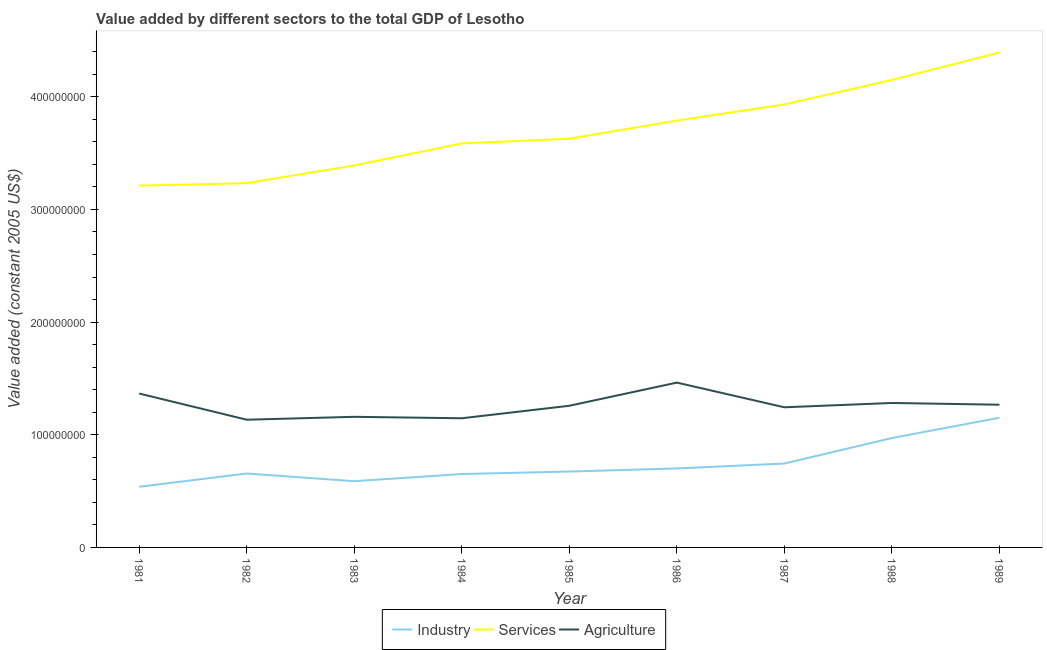Does the line corresponding to value added by agricultural sector intersect with the line corresponding to value added by industrial sector?
Offer a terse response. No. Is the number of lines equal to the number of legend labels?
Give a very brief answer. Yes. What is the value added by agricultural sector in 1989?
Offer a terse response. 1.27e+08. Across all years, what is the maximum value added by industrial sector?
Offer a very short reply. 1.15e+08. Across all years, what is the minimum value added by industrial sector?
Your answer should be compact. 5.38e+07. In which year was the value added by industrial sector maximum?
Your response must be concise. 1989. What is the total value added by industrial sector in the graph?
Provide a short and direct response. 6.68e+08. What is the difference between the value added by agricultural sector in 1982 and that in 1989?
Provide a short and direct response. -1.33e+07. What is the difference between the value added by services in 1984 and the value added by agricultural sector in 1982?
Keep it short and to the point. 2.45e+08. What is the average value added by services per year?
Ensure brevity in your answer.  3.70e+08. In the year 1987, what is the difference between the value added by agricultural sector and value added by services?
Offer a terse response. -2.69e+08. In how many years, is the value added by services greater than 40000000 US$?
Offer a very short reply. 9. What is the ratio of the value added by industrial sector in 1986 to that in 1987?
Offer a very short reply. 0.94. Is the difference between the value added by agricultural sector in 1985 and 1986 greater than the difference between the value added by services in 1985 and 1986?
Offer a very short reply. No. What is the difference between the highest and the second highest value added by industrial sector?
Provide a succinct answer. 1.80e+07. What is the difference between the highest and the lowest value added by agricultural sector?
Offer a very short reply. 3.29e+07. In how many years, is the value added by services greater than the average value added by services taken over all years?
Your answer should be very brief. 4. Is it the case that in every year, the sum of the value added by industrial sector and value added by services is greater than the value added by agricultural sector?
Give a very brief answer. Yes. Does the value added by services monotonically increase over the years?
Provide a short and direct response. Yes. Is the value added by industrial sector strictly less than the value added by services over the years?
Give a very brief answer. Yes. Are the values on the major ticks of Y-axis written in scientific E-notation?
Your answer should be compact. No. Does the graph contain any zero values?
Your response must be concise. No. Does the graph contain grids?
Keep it short and to the point. No. Where does the legend appear in the graph?
Your answer should be very brief. Bottom center. What is the title of the graph?
Offer a very short reply. Value added by different sectors to the total GDP of Lesotho. Does "Services" appear as one of the legend labels in the graph?
Keep it short and to the point. Yes. What is the label or title of the X-axis?
Ensure brevity in your answer.  Year. What is the label or title of the Y-axis?
Ensure brevity in your answer.  Value added (constant 2005 US$). What is the Value added (constant 2005 US$) of Industry in 1981?
Your response must be concise. 5.38e+07. What is the Value added (constant 2005 US$) in Services in 1981?
Provide a succinct answer. 3.21e+08. What is the Value added (constant 2005 US$) of Agriculture in 1981?
Ensure brevity in your answer.  1.37e+08. What is the Value added (constant 2005 US$) of Industry in 1982?
Your answer should be very brief. 6.56e+07. What is the Value added (constant 2005 US$) of Services in 1982?
Make the answer very short. 3.23e+08. What is the Value added (constant 2005 US$) of Agriculture in 1982?
Your answer should be very brief. 1.13e+08. What is the Value added (constant 2005 US$) of Industry in 1983?
Give a very brief answer. 5.88e+07. What is the Value added (constant 2005 US$) in Services in 1983?
Make the answer very short. 3.39e+08. What is the Value added (constant 2005 US$) in Agriculture in 1983?
Your answer should be very brief. 1.16e+08. What is the Value added (constant 2005 US$) in Industry in 1984?
Give a very brief answer. 6.51e+07. What is the Value added (constant 2005 US$) in Services in 1984?
Ensure brevity in your answer.  3.59e+08. What is the Value added (constant 2005 US$) of Agriculture in 1984?
Your answer should be very brief. 1.15e+08. What is the Value added (constant 2005 US$) in Industry in 1985?
Your answer should be compact. 6.73e+07. What is the Value added (constant 2005 US$) in Services in 1985?
Offer a terse response. 3.63e+08. What is the Value added (constant 2005 US$) of Agriculture in 1985?
Give a very brief answer. 1.26e+08. What is the Value added (constant 2005 US$) in Industry in 1986?
Ensure brevity in your answer.  7.01e+07. What is the Value added (constant 2005 US$) of Services in 1986?
Ensure brevity in your answer.  3.79e+08. What is the Value added (constant 2005 US$) of Agriculture in 1986?
Give a very brief answer. 1.46e+08. What is the Value added (constant 2005 US$) of Industry in 1987?
Your answer should be compact. 7.45e+07. What is the Value added (constant 2005 US$) of Services in 1987?
Keep it short and to the point. 3.93e+08. What is the Value added (constant 2005 US$) of Agriculture in 1987?
Your response must be concise. 1.24e+08. What is the Value added (constant 2005 US$) in Industry in 1988?
Provide a succinct answer. 9.71e+07. What is the Value added (constant 2005 US$) in Services in 1988?
Provide a short and direct response. 4.15e+08. What is the Value added (constant 2005 US$) of Agriculture in 1988?
Provide a succinct answer. 1.28e+08. What is the Value added (constant 2005 US$) in Industry in 1989?
Provide a short and direct response. 1.15e+08. What is the Value added (constant 2005 US$) in Services in 1989?
Provide a short and direct response. 4.39e+08. What is the Value added (constant 2005 US$) of Agriculture in 1989?
Your answer should be compact. 1.27e+08. Across all years, what is the maximum Value added (constant 2005 US$) in Industry?
Offer a terse response. 1.15e+08. Across all years, what is the maximum Value added (constant 2005 US$) in Services?
Offer a terse response. 4.39e+08. Across all years, what is the maximum Value added (constant 2005 US$) of Agriculture?
Your response must be concise. 1.46e+08. Across all years, what is the minimum Value added (constant 2005 US$) of Industry?
Your response must be concise. 5.38e+07. Across all years, what is the minimum Value added (constant 2005 US$) in Services?
Your response must be concise. 3.21e+08. Across all years, what is the minimum Value added (constant 2005 US$) of Agriculture?
Make the answer very short. 1.13e+08. What is the total Value added (constant 2005 US$) in Industry in the graph?
Ensure brevity in your answer.  6.68e+08. What is the total Value added (constant 2005 US$) of Services in the graph?
Provide a short and direct response. 3.33e+09. What is the total Value added (constant 2005 US$) in Agriculture in the graph?
Give a very brief answer. 1.13e+09. What is the difference between the Value added (constant 2005 US$) in Industry in 1981 and that in 1982?
Make the answer very short. -1.18e+07. What is the difference between the Value added (constant 2005 US$) of Services in 1981 and that in 1982?
Give a very brief answer. -2.20e+06. What is the difference between the Value added (constant 2005 US$) of Agriculture in 1981 and that in 1982?
Your response must be concise. 2.33e+07. What is the difference between the Value added (constant 2005 US$) in Industry in 1981 and that in 1983?
Keep it short and to the point. -4.95e+06. What is the difference between the Value added (constant 2005 US$) in Services in 1981 and that in 1983?
Make the answer very short. -1.79e+07. What is the difference between the Value added (constant 2005 US$) in Agriculture in 1981 and that in 1983?
Provide a short and direct response. 2.07e+07. What is the difference between the Value added (constant 2005 US$) in Industry in 1981 and that in 1984?
Keep it short and to the point. -1.13e+07. What is the difference between the Value added (constant 2005 US$) of Services in 1981 and that in 1984?
Your answer should be compact. -3.75e+07. What is the difference between the Value added (constant 2005 US$) in Agriculture in 1981 and that in 1984?
Provide a succinct answer. 2.20e+07. What is the difference between the Value added (constant 2005 US$) in Industry in 1981 and that in 1985?
Make the answer very short. -1.35e+07. What is the difference between the Value added (constant 2005 US$) in Services in 1981 and that in 1985?
Give a very brief answer. -4.16e+07. What is the difference between the Value added (constant 2005 US$) of Agriculture in 1981 and that in 1985?
Keep it short and to the point. 1.09e+07. What is the difference between the Value added (constant 2005 US$) of Industry in 1981 and that in 1986?
Give a very brief answer. -1.63e+07. What is the difference between the Value added (constant 2005 US$) of Services in 1981 and that in 1986?
Offer a terse response. -5.77e+07. What is the difference between the Value added (constant 2005 US$) in Agriculture in 1981 and that in 1986?
Your response must be concise. -9.69e+06. What is the difference between the Value added (constant 2005 US$) in Industry in 1981 and that in 1987?
Ensure brevity in your answer.  -2.06e+07. What is the difference between the Value added (constant 2005 US$) of Services in 1981 and that in 1987?
Provide a short and direct response. -7.21e+07. What is the difference between the Value added (constant 2005 US$) in Agriculture in 1981 and that in 1987?
Offer a terse response. 1.22e+07. What is the difference between the Value added (constant 2005 US$) of Industry in 1981 and that in 1988?
Offer a very short reply. -4.33e+07. What is the difference between the Value added (constant 2005 US$) of Services in 1981 and that in 1988?
Keep it short and to the point. -9.38e+07. What is the difference between the Value added (constant 2005 US$) of Agriculture in 1981 and that in 1988?
Offer a very short reply. 8.39e+06. What is the difference between the Value added (constant 2005 US$) in Industry in 1981 and that in 1989?
Offer a very short reply. -6.13e+07. What is the difference between the Value added (constant 2005 US$) of Services in 1981 and that in 1989?
Provide a short and direct response. -1.18e+08. What is the difference between the Value added (constant 2005 US$) in Agriculture in 1981 and that in 1989?
Ensure brevity in your answer.  9.94e+06. What is the difference between the Value added (constant 2005 US$) of Industry in 1982 and that in 1983?
Your answer should be compact. 6.82e+06. What is the difference between the Value added (constant 2005 US$) in Services in 1982 and that in 1983?
Provide a succinct answer. -1.57e+07. What is the difference between the Value added (constant 2005 US$) in Agriculture in 1982 and that in 1983?
Ensure brevity in your answer.  -2.58e+06. What is the difference between the Value added (constant 2005 US$) of Industry in 1982 and that in 1984?
Your answer should be compact. 4.61e+05. What is the difference between the Value added (constant 2005 US$) in Services in 1982 and that in 1984?
Ensure brevity in your answer.  -3.53e+07. What is the difference between the Value added (constant 2005 US$) in Agriculture in 1982 and that in 1984?
Your answer should be very brief. -1.29e+06. What is the difference between the Value added (constant 2005 US$) in Industry in 1982 and that in 1985?
Make the answer very short. -1.74e+06. What is the difference between the Value added (constant 2005 US$) in Services in 1982 and that in 1985?
Your answer should be very brief. -3.95e+07. What is the difference between the Value added (constant 2005 US$) of Agriculture in 1982 and that in 1985?
Provide a succinct answer. -1.24e+07. What is the difference between the Value added (constant 2005 US$) in Industry in 1982 and that in 1986?
Offer a terse response. -4.51e+06. What is the difference between the Value added (constant 2005 US$) in Services in 1982 and that in 1986?
Ensure brevity in your answer.  -5.55e+07. What is the difference between the Value added (constant 2005 US$) in Agriculture in 1982 and that in 1986?
Provide a succinct answer. -3.29e+07. What is the difference between the Value added (constant 2005 US$) of Industry in 1982 and that in 1987?
Provide a succinct answer. -8.85e+06. What is the difference between the Value added (constant 2005 US$) of Services in 1982 and that in 1987?
Ensure brevity in your answer.  -6.99e+07. What is the difference between the Value added (constant 2005 US$) of Agriculture in 1982 and that in 1987?
Your answer should be compact. -1.10e+07. What is the difference between the Value added (constant 2005 US$) in Industry in 1982 and that in 1988?
Offer a very short reply. -3.15e+07. What is the difference between the Value added (constant 2005 US$) of Services in 1982 and that in 1988?
Give a very brief answer. -9.16e+07. What is the difference between the Value added (constant 2005 US$) in Agriculture in 1982 and that in 1988?
Your response must be concise. -1.49e+07. What is the difference between the Value added (constant 2005 US$) in Industry in 1982 and that in 1989?
Your response must be concise. -4.95e+07. What is the difference between the Value added (constant 2005 US$) in Services in 1982 and that in 1989?
Provide a short and direct response. -1.16e+08. What is the difference between the Value added (constant 2005 US$) in Agriculture in 1982 and that in 1989?
Ensure brevity in your answer.  -1.33e+07. What is the difference between the Value added (constant 2005 US$) of Industry in 1983 and that in 1984?
Give a very brief answer. -6.36e+06. What is the difference between the Value added (constant 2005 US$) of Services in 1983 and that in 1984?
Provide a succinct answer. -1.96e+07. What is the difference between the Value added (constant 2005 US$) of Agriculture in 1983 and that in 1984?
Provide a short and direct response. 1.29e+06. What is the difference between the Value added (constant 2005 US$) in Industry in 1983 and that in 1985?
Keep it short and to the point. -8.56e+06. What is the difference between the Value added (constant 2005 US$) of Services in 1983 and that in 1985?
Offer a very short reply. -2.38e+07. What is the difference between the Value added (constant 2005 US$) in Agriculture in 1983 and that in 1985?
Provide a short and direct response. -9.80e+06. What is the difference between the Value added (constant 2005 US$) of Industry in 1983 and that in 1986?
Make the answer very short. -1.13e+07. What is the difference between the Value added (constant 2005 US$) of Services in 1983 and that in 1986?
Your answer should be compact. -3.99e+07. What is the difference between the Value added (constant 2005 US$) of Agriculture in 1983 and that in 1986?
Your response must be concise. -3.04e+07. What is the difference between the Value added (constant 2005 US$) in Industry in 1983 and that in 1987?
Provide a succinct answer. -1.57e+07. What is the difference between the Value added (constant 2005 US$) of Services in 1983 and that in 1987?
Make the answer very short. -5.42e+07. What is the difference between the Value added (constant 2005 US$) in Agriculture in 1983 and that in 1987?
Your answer should be compact. -8.44e+06. What is the difference between the Value added (constant 2005 US$) in Industry in 1983 and that in 1988?
Offer a very short reply. -3.83e+07. What is the difference between the Value added (constant 2005 US$) of Services in 1983 and that in 1988?
Your answer should be very brief. -7.59e+07. What is the difference between the Value added (constant 2005 US$) of Agriculture in 1983 and that in 1988?
Give a very brief answer. -1.23e+07. What is the difference between the Value added (constant 2005 US$) of Industry in 1983 and that in 1989?
Ensure brevity in your answer.  -5.63e+07. What is the difference between the Value added (constant 2005 US$) in Services in 1983 and that in 1989?
Make the answer very short. -1.00e+08. What is the difference between the Value added (constant 2005 US$) in Agriculture in 1983 and that in 1989?
Keep it short and to the point. -1.07e+07. What is the difference between the Value added (constant 2005 US$) in Industry in 1984 and that in 1985?
Offer a very short reply. -2.20e+06. What is the difference between the Value added (constant 2005 US$) in Services in 1984 and that in 1985?
Give a very brief answer. -4.17e+06. What is the difference between the Value added (constant 2005 US$) of Agriculture in 1984 and that in 1985?
Offer a very short reply. -1.11e+07. What is the difference between the Value added (constant 2005 US$) of Industry in 1984 and that in 1986?
Your answer should be very brief. -4.97e+06. What is the difference between the Value added (constant 2005 US$) in Services in 1984 and that in 1986?
Make the answer very short. -2.03e+07. What is the difference between the Value added (constant 2005 US$) in Agriculture in 1984 and that in 1986?
Provide a short and direct response. -3.17e+07. What is the difference between the Value added (constant 2005 US$) of Industry in 1984 and that in 1987?
Offer a very short reply. -9.31e+06. What is the difference between the Value added (constant 2005 US$) of Services in 1984 and that in 1987?
Make the answer very short. -3.46e+07. What is the difference between the Value added (constant 2005 US$) in Agriculture in 1984 and that in 1987?
Offer a very short reply. -9.73e+06. What is the difference between the Value added (constant 2005 US$) in Industry in 1984 and that in 1988?
Provide a succinct answer. -3.20e+07. What is the difference between the Value added (constant 2005 US$) in Services in 1984 and that in 1988?
Your answer should be compact. -5.63e+07. What is the difference between the Value added (constant 2005 US$) in Agriculture in 1984 and that in 1988?
Your response must be concise. -1.36e+07. What is the difference between the Value added (constant 2005 US$) in Industry in 1984 and that in 1989?
Provide a succinct answer. -5.00e+07. What is the difference between the Value added (constant 2005 US$) in Services in 1984 and that in 1989?
Provide a succinct answer. -8.06e+07. What is the difference between the Value added (constant 2005 US$) of Agriculture in 1984 and that in 1989?
Offer a terse response. -1.20e+07. What is the difference between the Value added (constant 2005 US$) of Industry in 1985 and that in 1986?
Your response must be concise. -2.77e+06. What is the difference between the Value added (constant 2005 US$) of Services in 1985 and that in 1986?
Provide a succinct answer. -1.61e+07. What is the difference between the Value added (constant 2005 US$) in Agriculture in 1985 and that in 1986?
Ensure brevity in your answer.  -2.06e+07. What is the difference between the Value added (constant 2005 US$) in Industry in 1985 and that in 1987?
Give a very brief answer. -7.11e+06. What is the difference between the Value added (constant 2005 US$) in Services in 1985 and that in 1987?
Your answer should be very brief. -3.04e+07. What is the difference between the Value added (constant 2005 US$) in Agriculture in 1985 and that in 1987?
Give a very brief answer. 1.36e+06. What is the difference between the Value added (constant 2005 US$) in Industry in 1985 and that in 1988?
Your response must be concise. -2.98e+07. What is the difference between the Value added (constant 2005 US$) of Services in 1985 and that in 1988?
Your answer should be compact. -5.22e+07. What is the difference between the Value added (constant 2005 US$) of Agriculture in 1985 and that in 1988?
Ensure brevity in your answer.  -2.48e+06. What is the difference between the Value added (constant 2005 US$) in Industry in 1985 and that in 1989?
Provide a short and direct response. -4.78e+07. What is the difference between the Value added (constant 2005 US$) of Services in 1985 and that in 1989?
Offer a very short reply. -7.65e+07. What is the difference between the Value added (constant 2005 US$) of Agriculture in 1985 and that in 1989?
Ensure brevity in your answer.  -9.31e+05. What is the difference between the Value added (constant 2005 US$) of Industry in 1986 and that in 1987?
Keep it short and to the point. -4.34e+06. What is the difference between the Value added (constant 2005 US$) of Services in 1986 and that in 1987?
Your answer should be very brief. -1.43e+07. What is the difference between the Value added (constant 2005 US$) in Agriculture in 1986 and that in 1987?
Your answer should be very brief. 2.19e+07. What is the difference between the Value added (constant 2005 US$) in Industry in 1986 and that in 1988?
Keep it short and to the point. -2.70e+07. What is the difference between the Value added (constant 2005 US$) in Services in 1986 and that in 1988?
Provide a succinct answer. -3.61e+07. What is the difference between the Value added (constant 2005 US$) in Agriculture in 1986 and that in 1988?
Your answer should be compact. 1.81e+07. What is the difference between the Value added (constant 2005 US$) of Industry in 1986 and that in 1989?
Give a very brief answer. -4.50e+07. What is the difference between the Value added (constant 2005 US$) of Services in 1986 and that in 1989?
Give a very brief answer. -6.04e+07. What is the difference between the Value added (constant 2005 US$) in Agriculture in 1986 and that in 1989?
Make the answer very short. 1.96e+07. What is the difference between the Value added (constant 2005 US$) of Industry in 1987 and that in 1988?
Provide a succinct answer. -2.27e+07. What is the difference between the Value added (constant 2005 US$) of Services in 1987 and that in 1988?
Make the answer very short. -2.18e+07. What is the difference between the Value added (constant 2005 US$) of Agriculture in 1987 and that in 1988?
Your answer should be compact. -3.84e+06. What is the difference between the Value added (constant 2005 US$) in Industry in 1987 and that in 1989?
Your response must be concise. -4.07e+07. What is the difference between the Value added (constant 2005 US$) in Services in 1987 and that in 1989?
Provide a succinct answer. -4.61e+07. What is the difference between the Value added (constant 2005 US$) of Agriculture in 1987 and that in 1989?
Your answer should be compact. -2.29e+06. What is the difference between the Value added (constant 2005 US$) of Industry in 1988 and that in 1989?
Keep it short and to the point. -1.80e+07. What is the difference between the Value added (constant 2005 US$) of Services in 1988 and that in 1989?
Offer a very short reply. -2.43e+07. What is the difference between the Value added (constant 2005 US$) of Agriculture in 1988 and that in 1989?
Offer a terse response. 1.55e+06. What is the difference between the Value added (constant 2005 US$) of Industry in 1981 and the Value added (constant 2005 US$) of Services in 1982?
Keep it short and to the point. -2.69e+08. What is the difference between the Value added (constant 2005 US$) in Industry in 1981 and the Value added (constant 2005 US$) in Agriculture in 1982?
Your response must be concise. -5.95e+07. What is the difference between the Value added (constant 2005 US$) in Services in 1981 and the Value added (constant 2005 US$) in Agriculture in 1982?
Provide a succinct answer. 2.08e+08. What is the difference between the Value added (constant 2005 US$) of Industry in 1981 and the Value added (constant 2005 US$) of Services in 1983?
Give a very brief answer. -2.85e+08. What is the difference between the Value added (constant 2005 US$) in Industry in 1981 and the Value added (constant 2005 US$) in Agriculture in 1983?
Offer a very short reply. -6.21e+07. What is the difference between the Value added (constant 2005 US$) of Services in 1981 and the Value added (constant 2005 US$) of Agriculture in 1983?
Keep it short and to the point. 2.05e+08. What is the difference between the Value added (constant 2005 US$) in Industry in 1981 and the Value added (constant 2005 US$) in Services in 1984?
Offer a terse response. -3.05e+08. What is the difference between the Value added (constant 2005 US$) of Industry in 1981 and the Value added (constant 2005 US$) of Agriculture in 1984?
Make the answer very short. -6.08e+07. What is the difference between the Value added (constant 2005 US$) of Services in 1981 and the Value added (constant 2005 US$) of Agriculture in 1984?
Give a very brief answer. 2.06e+08. What is the difference between the Value added (constant 2005 US$) of Industry in 1981 and the Value added (constant 2005 US$) of Services in 1985?
Ensure brevity in your answer.  -3.09e+08. What is the difference between the Value added (constant 2005 US$) in Industry in 1981 and the Value added (constant 2005 US$) in Agriculture in 1985?
Provide a short and direct response. -7.19e+07. What is the difference between the Value added (constant 2005 US$) in Services in 1981 and the Value added (constant 2005 US$) in Agriculture in 1985?
Your answer should be very brief. 1.95e+08. What is the difference between the Value added (constant 2005 US$) in Industry in 1981 and the Value added (constant 2005 US$) in Services in 1986?
Provide a succinct answer. -3.25e+08. What is the difference between the Value added (constant 2005 US$) of Industry in 1981 and the Value added (constant 2005 US$) of Agriculture in 1986?
Offer a terse response. -9.25e+07. What is the difference between the Value added (constant 2005 US$) of Services in 1981 and the Value added (constant 2005 US$) of Agriculture in 1986?
Provide a succinct answer. 1.75e+08. What is the difference between the Value added (constant 2005 US$) of Industry in 1981 and the Value added (constant 2005 US$) of Services in 1987?
Offer a terse response. -3.39e+08. What is the difference between the Value added (constant 2005 US$) in Industry in 1981 and the Value added (constant 2005 US$) in Agriculture in 1987?
Your answer should be very brief. -7.05e+07. What is the difference between the Value added (constant 2005 US$) of Services in 1981 and the Value added (constant 2005 US$) of Agriculture in 1987?
Provide a succinct answer. 1.97e+08. What is the difference between the Value added (constant 2005 US$) in Industry in 1981 and the Value added (constant 2005 US$) in Services in 1988?
Offer a very short reply. -3.61e+08. What is the difference between the Value added (constant 2005 US$) of Industry in 1981 and the Value added (constant 2005 US$) of Agriculture in 1988?
Provide a succinct answer. -7.44e+07. What is the difference between the Value added (constant 2005 US$) in Services in 1981 and the Value added (constant 2005 US$) in Agriculture in 1988?
Offer a very short reply. 1.93e+08. What is the difference between the Value added (constant 2005 US$) in Industry in 1981 and the Value added (constant 2005 US$) in Services in 1989?
Give a very brief answer. -3.85e+08. What is the difference between the Value added (constant 2005 US$) of Industry in 1981 and the Value added (constant 2005 US$) of Agriculture in 1989?
Offer a very short reply. -7.28e+07. What is the difference between the Value added (constant 2005 US$) in Services in 1981 and the Value added (constant 2005 US$) in Agriculture in 1989?
Offer a terse response. 1.94e+08. What is the difference between the Value added (constant 2005 US$) in Industry in 1982 and the Value added (constant 2005 US$) in Services in 1983?
Offer a terse response. -2.73e+08. What is the difference between the Value added (constant 2005 US$) of Industry in 1982 and the Value added (constant 2005 US$) of Agriculture in 1983?
Keep it short and to the point. -5.03e+07. What is the difference between the Value added (constant 2005 US$) of Services in 1982 and the Value added (constant 2005 US$) of Agriculture in 1983?
Offer a terse response. 2.07e+08. What is the difference between the Value added (constant 2005 US$) of Industry in 1982 and the Value added (constant 2005 US$) of Services in 1984?
Your answer should be very brief. -2.93e+08. What is the difference between the Value added (constant 2005 US$) of Industry in 1982 and the Value added (constant 2005 US$) of Agriculture in 1984?
Provide a short and direct response. -4.90e+07. What is the difference between the Value added (constant 2005 US$) of Services in 1982 and the Value added (constant 2005 US$) of Agriculture in 1984?
Make the answer very short. 2.09e+08. What is the difference between the Value added (constant 2005 US$) of Industry in 1982 and the Value added (constant 2005 US$) of Services in 1985?
Make the answer very short. -2.97e+08. What is the difference between the Value added (constant 2005 US$) of Industry in 1982 and the Value added (constant 2005 US$) of Agriculture in 1985?
Provide a short and direct response. -6.01e+07. What is the difference between the Value added (constant 2005 US$) in Services in 1982 and the Value added (constant 2005 US$) in Agriculture in 1985?
Your answer should be very brief. 1.98e+08. What is the difference between the Value added (constant 2005 US$) of Industry in 1982 and the Value added (constant 2005 US$) of Services in 1986?
Your answer should be compact. -3.13e+08. What is the difference between the Value added (constant 2005 US$) in Industry in 1982 and the Value added (constant 2005 US$) in Agriculture in 1986?
Offer a terse response. -8.07e+07. What is the difference between the Value added (constant 2005 US$) in Services in 1982 and the Value added (constant 2005 US$) in Agriculture in 1986?
Offer a very short reply. 1.77e+08. What is the difference between the Value added (constant 2005 US$) in Industry in 1982 and the Value added (constant 2005 US$) in Services in 1987?
Give a very brief answer. -3.28e+08. What is the difference between the Value added (constant 2005 US$) of Industry in 1982 and the Value added (constant 2005 US$) of Agriculture in 1987?
Offer a terse response. -5.88e+07. What is the difference between the Value added (constant 2005 US$) of Services in 1982 and the Value added (constant 2005 US$) of Agriculture in 1987?
Provide a succinct answer. 1.99e+08. What is the difference between the Value added (constant 2005 US$) in Industry in 1982 and the Value added (constant 2005 US$) in Services in 1988?
Offer a terse response. -3.49e+08. What is the difference between the Value added (constant 2005 US$) of Industry in 1982 and the Value added (constant 2005 US$) of Agriculture in 1988?
Your answer should be compact. -6.26e+07. What is the difference between the Value added (constant 2005 US$) in Services in 1982 and the Value added (constant 2005 US$) in Agriculture in 1988?
Offer a terse response. 1.95e+08. What is the difference between the Value added (constant 2005 US$) of Industry in 1982 and the Value added (constant 2005 US$) of Services in 1989?
Your answer should be compact. -3.74e+08. What is the difference between the Value added (constant 2005 US$) of Industry in 1982 and the Value added (constant 2005 US$) of Agriculture in 1989?
Your answer should be compact. -6.11e+07. What is the difference between the Value added (constant 2005 US$) of Services in 1982 and the Value added (constant 2005 US$) of Agriculture in 1989?
Provide a succinct answer. 1.97e+08. What is the difference between the Value added (constant 2005 US$) in Industry in 1983 and the Value added (constant 2005 US$) in Services in 1984?
Ensure brevity in your answer.  -3.00e+08. What is the difference between the Value added (constant 2005 US$) of Industry in 1983 and the Value added (constant 2005 US$) of Agriculture in 1984?
Offer a terse response. -5.59e+07. What is the difference between the Value added (constant 2005 US$) in Services in 1983 and the Value added (constant 2005 US$) in Agriculture in 1984?
Offer a terse response. 2.24e+08. What is the difference between the Value added (constant 2005 US$) in Industry in 1983 and the Value added (constant 2005 US$) in Services in 1985?
Give a very brief answer. -3.04e+08. What is the difference between the Value added (constant 2005 US$) of Industry in 1983 and the Value added (constant 2005 US$) of Agriculture in 1985?
Your response must be concise. -6.70e+07. What is the difference between the Value added (constant 2005 US$) in Services in 1983 and the Value added (constant 2005 US$) in Agriculture in 1985?
Your answer should be compact. 2.13e+08. What is the difference between the Value added (constant 2005 US$) of Industry in 1983 and the Value added (constant 2005 US$) of Services in 1986?
Your response must be concise. -3.20e+08. What is the difference between the Value added (constant 2005 US$) of Industry in 1983 and the Value added (constant 2005 US$) of Agriculture in 1986?
Your answer should be compact. -8.75e+07. What is the difference between the Value added (constant 2005 US$) in Services in 1983 and the Value added (constant 2005 US$) in Agriculture in 1986?
Offer a very short reply. 1.93e+08. What is the difference between the Value added (constant 2005 US$) in Industry in 1983 and the Value added (constant 2005 US$) in Services in 1987?
Give a very brief answer. -3.34e+08. What is the difference between the Value added (constant 2005 US$) of Industry in 1983 and the Value added (constant 2005 US$) of Agriculture in 1987?
Make the answer very short. -6.56e+07. What is the difference between the Value added (constant 2005 US$) of Services in 1983 and the Value added (constant 2005 US$) of Agriculture in 1987?
Make the answer very short. 2.15e+08. What is the difference between the Value added (constant 2005 US$) of Industry in 1983 and the Value added (constant 2005 US$) of Services in 1988?
Make the answer very short. -3.56e+08. What is the difference between the Value added (constant 2005 US$) of Industry in 1983 and the Value added (constant 2005 US$) of Agriculture in 1988?
Provide a succinct answer. -6.94e+07. What is the difference between the Value added (constant 2005 US$) in Services in 1983 and the Value added (constant 2005 US$) in Agriculture in 1988?
Offer a very short reply. 2.11e+08. What is the difference between the Value added (constant 2005 US$) of Industry in 1983 and the Value added (constant 2005 US$) of Services in 1989?
Provide a short and direct response. -3.80e+08. What is the difference between the Value added (constant 2005 US$) in Industry in 1983 and the Value added (constant 2005 US$) in Agriculture in 1989?
Offer a terse response. -6.79e+07. What is the difference between the Value added (constant 2005 US$) of Services in 1983 and the Value added (constant 2005 US$) of Agriculture in 1989?
Provide a succinct answer. 2.12e+08. What is the difference between the Value added (constant 2005 US$) in Industry in 1984 and the Value added (constant 2005 US$) in Services in 1985?
Ensure brevity in your answer.  -2.98e+08. What is the difference between the Value added (constant 2005 US$) in Industry in 1984 and the Value added (constant 2005 US$) in Agriculture in 1985?
Ensure brevity in your answer.  -6.06e+07. What is the difference between the Value added (constant 2005 US$) of Services in 1984 and the Value added (constant 2005 US$) of Agriculture in 1985?
Your answer should be very brief. 2.33e+08. What is the difference between the Value added (constant 2005 US$) of Industry in 1984 and the Value added (constant 2005 US$) of Services in 1986?
Your answer should be compact. -3.14e+08. What is the difference between the Value added (constant 2005 US$) in Industry in 1984 and the Value added (constant 2005 US$) in Agriculture in 1986?
Provide a succinct answer. -8.11e+07. What is the difference between the Value added (constant 2005 US$) in Services in 1984 and the Value added (constant 2005 US$) in Agriculture in 1986?
Ensure brevity in your answer.  2.12e+08. What is the difference between the Value added (constant 2005 US$) in Industry in 1984 and the Value added (constant 2005 US$) in Services in 1987?
Make the answer very short. -3.28e+08. What is the difference between the Value added (constant 2005 US$) in Industry in 1984 and the Value added (constant 2005 US$) in Agriculture in 1987?
Ensure brevity in your answer.  -5.92e+07. What is the difference between the Value added (constant 2005 US$) of Services in 1984 and the Value added (constant 2005 US$) of Agriculture in 1987?
Offer a very short reply. 2.34e+08. What is the difference between the Value added (constant 2005 US$) of Industry in 1984 and the Value added (constant 2005 US$) of Services in 1988?
Make the answer very short. -3.50e+08. What is the difference between the Value added (constant 2005 US$) in Industry in 1984 and the Value added (constant 2005 US$) in Agriculture in 1988?
Your answer should be very brief. -6.31e+07. What is the difference between the Value added (constant 2005 US$) of Services in 1984 and the Value added (constant 2005 US$) of Agriculture in 1988?
Give a very brief answer. 2.30e+08. What is the difference between the Value added (constant 2005 US$) of Industry in 1984 and the Value added (constant 2005 US$) of Services in 1989?
Give a very brief answer. -3.74e+08. What is the difference between the Value added (constant 2005 US$) of Industry in 1984 and the Value added (constant 2005 US$) of Agriculture in 1989?
Offer a very short reply. -6.15e+07. What is the difference between the Value added (constant 2005 US$) of Services in 1984 and the Value added (constant 2005 US$) of Agriculture in 1989?
Your answer should be compact. 2.32e+08. What is the difference between the Value added (constant 2005 US$) of Industry in 1985 and the Value added (constant 2005 US$) of Services in 1986?
Ensure brevity in your answer.  -3.12e+08. What is the difference between the Value added (constant 2005 US$) of Industry in 1985 and the Value added (constant 2005 US$) of Agriculture in 1986?
Ensure brevity in your answer.  -7.90e+07. What is the difference between the Value added (constant 2005 US$) of Services in 1985 and the Value added (constant 2005 US$) of Agriculture in 1986?
Your answer should be very brief. 2.16e+08. What is the difference between the Value added (constant 2005 US$) in Industry in 1985 and the Value added (constant 2005 US$) in Services in 1987?
Ensure brevity in your answer.  -3.26e+08. What is the difference between the Value added (constant 2005 US$) of Industry in 1985 and the Value added (constant 2005 US$) of Agriculture in 1987?
Make the answer very short. -5.70e+07. What is the difference between the Value added (constant 2005 US$) in Services in 1985 and the Value added (constant 2005 US$) in Agriculture in 1987?
Your response must be concise. 2.38e+08. What is the difference between the Value added (constant 2005 US$) of Industry in 1985 and the Value added (constant 2005 US$) of Services in 1988?
Provide a succinct answer. -3.48e+08. What is the difference between the Value added (constant 2005 US$) in Industry in 1985 and the Value added (constant 2005 US$) in Agriculture in 1988?
Give a very brief answer. -6.09e+07. What is the difference between the Value added (constant 2005 US$) in Services in 1985 and the Value added (constant 2005 US$) in Agriculture in 1988?
Provide a succinct answer. 2.35e+08. What is the difference between the Value added (constant 2005 US$) of Industry in 1985 and the Value added (constant 2005 US$) of Services in 1989?
Keep it short and to the point. -3.72e+08. What is the difference between the Value added (constant 2005 US$) in Industry in 1985 and the Value added (constant 2005 US$) in Agriculture in 1989?
Give a very brief answer. -5.93e+07. What is the difference between the Value added (constant 2005 US$) of Services in 1985 and the Value added (constant 2005 US$) of Agriculture in 1989?
Ensure brevity in your answer.  2.36e+08. What is the difference between the Value added (constant 2005 US$) of Industry in 1986 and the Value added (constant 2005 US$) of Services in 1987?
Offer a terse response. -3.23e+08. What is the difference between the Value added (constant 2005 US$) in Industry in 1986 and the Value added (constant 2005 US$) in Agriculture in 1987?
Keep it short and to the point. -5.43e+07. What is the difference between the Value added (constant 2005 US$) of Services in 1986 and the Value added (constant 2005 US$) of Agriculture in 1987?
Ensure brevity in your answer.  2.55e+08. What is the difference between the Value added (constant 2005 US$) in Industry in 1986 and the Value added (constant 2005 US$) in Services in 1988?
Your answer should be very brief. -3.45e+08. What is the difference between the Value added (constant 2005 US$) in Industry in 1986 and the Value added (constant 2005 US$) in Agriculture in 1988?
Your answer should be very brief. -5.81e+07. What is the difference between the Value added (constant 2005 US$) of Services in 1986 and the Value added (constant 2005 US$) of Agriculture in 1988?
Offer a terse response. 2.51e+08. What is the difference between the Value added (constant 2005 US$) of Industry in 1986 and the Value added (constant 2005 US$) of Services in 1989?
Keep it short and to the point. -3.69e+08. What is the difference between the Value added (constant 2005 US$) in Industry in 1986 and the Value added (constant 2005 US$) in Agriculture in 1989?
Provide a short and direct response. -5.66e+07. What is the difference between the Value added (constant 2005 US$) of Services in 1986 and the Value added (constant 2005 US$) of Agriculture in 1989?
Ensure brevity in your answer.  2.52e+08. What is the difference between the Value added (constant 2005 US$) in Industry in 1987 and the Value added (constant 2005 US$) in Services in 1988?
Provide a succinct answer. -3.41e+08. What is the difference between the Value added (constant 2005 US$) of Industry in 1987 and the Value added (constant 2005 US$) of Agriculture in 1988?
Make the answer very short. -5.38e+07. What is the difference between the Value added (constant 2005 US$) of Services in 1987 and the Value added (constant 2005 US$) of Agriculture in 1988?
Offer a terse response. 2.65e+08. What is the difference between the Value added (constant 2005 US$) of Industry in 1987 and the Value added (constant 2005 US$) of Services in 1989?
Give a very brief answer. -3.65e+08. What is the difference between the Value added (constant 2005 US$) in Industry in 1987 and the Value added (constant 2005 US$) in Agriculture in 1989?
Give a very brief answer. -5.22e+07. What is the difference between the Value added (constant 2005 US$) of Services in 1987 and the Value added (constant 2005 US$) of Agriculture in 1989?
Keep it short and to the point. 2.67e+08. What is the difference between the Value added (constant 2005 US$) of Industry in 1988 and the Value added (constant 2005 US$) of Services in 1989?
Provide a short and direct response. -3.42e+08. What is the difference between the Value added (constant 2005 US$) in Industry in 1988 and the Value added (constant 2005 US$) in Agriculture in 1989?
Your answer should be compact. -2.96e+07. What is the difference between the Value added (constant 2005 US$) in Services in 1988 and the Value added (constant 2005 US$) in Agriculture in 1989?
Make the answer very short. 2.88e+08. What is the average Value added (constant 2005 US$) of Industry per year?
Offer a very short reply. 7.42e+07. What is the average Value added (constant 2005 US$) in Services per year?
Your answer should be very brief. 3.70e+08. What is the average Value added (constant 2005 US$) of Agriculture per year?
Keep it short and to the point. 1.26e+08. In the year 1981, what is the difference between the Value added (constant 2005 US$) in Industry and Value added (constant 2005 US$) in Services?
Offer a terse response. -2.67e+08. In the year 1981, what is the difference between the Value added (constant 2005 US$) in Industry and Value added (constant 2005 US$) in Agriculture?
Your answer should be compact. -8.28e+07. In the year 1981, what is the difference between the Value added (constant 2005 US$) in Services and Value added (constant 2005 US$) in Agriculture?
Ensure brevity in your answer.  1.85e+08. In the year 1982, what is the difference between the Value added (constant 2005 US$) in Industry and Value added (constant 2005 US$) in Services?
Make the answer very short. -2.58e+08. In the year 1982, what is the difference between the Value added (constant 2005 US$) in Industry and Value added (constant 2005 US$) in Agriculture?
Keep it short and to the point. -4.77e+07. In the year 1982, what is the difference between the Value added (constant 2005 US$) of Services and Value added (constant 2005 US$) of Agriculture?
Your answer should be compact. 2.10e+08. In the year 1983, what is the difference between the Value added (constant 2005 US$) in Industry and Value added (constant 2005 US$) in Services?
Keep it short and to the point. -2.80e+08. In the year 1983, what is the difference between the Value added (constant 2005 US$) of Industry and Value added (constant 2005 US$) of Agriculture?
Your response must be concise. -5.71e+07. In the year 1983, what is the difference between the Value added (constant 2005 US$) of Services and Value added (constant 2005 US$) of Agriculture?
Provide a succinct answer. 2.23e+08. In the year 1984, what is the difference between the Value added (constant 2005 US$) of Industry and Value added (constant 2005 US$) of Services?
Ensure brevity in your answer.  -2.93e+08. In the year 1984, what is the difference between the Value added (constant 2005 US$) in Industry and Value added (constant 2005 US$) in Agriculture?
Give a very brief answer. -4.95e+07. In the year 1984, what is the difference between the Value added (constant 2005 US$) of Services and Value added (constant 2005 US$) of Agriculture?
Provide a short and direct response. 2.44e+08. In the year 1985, what is the difference between the Value added (constant 2005 US$) of Industry and Value added (constant 2005 US$) of Services?
Provide a short and direct response. -2.95e+08. In the year 1985, what is the difference between the Value added (constant 2005 US$) of Industry and Value added (constant 2005 US$) of Agriculture?
Keep it short and to the point. -5.84e+07. In the year 1985, what is the difference between the Value added (constant 2005 US$) in Services and Value added (constant 2005 US$) in Agriculture?
Ensure brevity in your answer.  2.37e+08. In the year 1986, what is the difference between the Value added (constant 2005 US$) in Industry and Value added (constant 2005 US$) in Services?
Offer a very short reply. -3.09e+08. In the year 1986, what is the difference between the Value added (constant 2005 US$) in Industry and Value added (constant 2005 US$) in Agriculture?
Provide a short and direct response. -7.62e+07. In the year 1986, what is the difference between the Value added (constant 2005 US$) of Services and Value added (constant 2005 US$) of Agriculture?
Keep it short and to the point. 2.33e+08. In the year 1987, what is the difference between the Value added (constant 2005 US$) of Industry and Value added (constant 2005 US$) of Services?
Your answer should be very brief. -3.19e+08. In the year 1987, what is the difference between the Value added (constant 2005 US$) in Industry and Value added (constant 2005 US$) in Agriculture?
Offer a very short reply. -4.99e+07. In the year 1987, what is the difference between the Value added (constant 2005 US$) in Services and Value added (constant 2005 US$) in Agriculture?
Provide a succinct answer. 2.69e+08. In the year 1988, what is the difference between the Value added (constant 2005 US$) in Industry and Value added (constant 2005 US$) in Services?
Ensure brevity in your answer.  -3.18e+08. In the year 1988, what is the difference between the Value added (constant 2005 US$) in Industry and Value added (constant 2005 US$) in Agriculture?
Make the answer very short. -3.11e+07. In the year 1988, what is the difference between the Value added (constant 2005 US$) in Services and Value added (constant 2005 US$) in Agriculture?
Offer a very short reply. 2.87e+08. In the year 1989, what is the difference between the Value added (constant 2005 US$) of Industry and Value added (constant 2005 US$) of Services?
Offer a terse response. -3.24e+08. In the year 1989, what is the difference between the Value added (constant 2005 US$) of Industry and Value added (constant 2005 US$) of Agriculture?
Offer a terse response. -1.15e+07. In the year 1989, what is the difference between the Value added (constant 2005 US$) of Services and Value added (constant 2005 US$) of Agriculture?
Ensure brevity in your answer.  3.13e+08. What is the ratio of the Value added (constant 2005 US$) of Industry in 1981 to that in 1982?
Keep it short and to the point. 0.82. What is the ratio of the Value added (constant 2005 US$) of Agriculture in 1981 to that in 1982?
Keep it short and to the point. 1.21. What is the ratio of the Value added (constant 2005 US$) of Industry in 1981 to that in 1983?
Your answer should be compact. 0.92. What is the ratio of the Value added (constant 2005 US$) in Services in 1981 to that in 1983?
Provide a short and direct response. 0.95. What is the ratio of the Value added (constant 2005 US$) of Agriculture in 1981 to that in 1983?
Provide a succinct answer. 1.18. What is the ratio of the Value added (constant 2005 US$) of Industry in 1981 to that in 1984?
Keep it short and to the point. 0.83. What is the ratio of the Value added (constant 2005 US$) of Services in 1981 to that in 1984?
Offer a very short reply. 0.9. What is the ratio of the Value added (constant 2005 US$) of Agriculture in 1981 to that in 1984?
Keep it short and to the point. 1.19. What is the ratio of the Value added (constant 2005 US$) of Industry in 1981 to that in 1985?
Your answer should be compact. 0.8. What is the ratio of the Value added (constant 2005 US$) of Services in 1981 to that in 1985?
Offer a terse response. 0.89. What is the ratio of the Value added (constant 2005 US$) in Agriculture in 1981 to that in 1985?
Ensure brevity in your answer.  1.09. What is the ratio of the Value added (constant 2005 US$) in Industry in 1981 to that in 1986?
Keep it short and to the point. 0.77. What is the ratio of the Value added (constant 2005 US$) in Services in 1981 to that in 1986?
Give a very brief answer. 0.85. What is the ratio of the Value added (constant 2005 US$) of Agriculture in 1981 to that in 1986?
Provide a succinct answer. 0.93. What is the ratio of the Value added (constant 2005 US$) of Industry in 1981 to that in 1987?
Offer a very short reply. 0.72. What is the ratio of the Value added (constant 2005 US$) in Services in 1981 to that in 1987?
Ensure brevity in your answer.  0.82. What is the ratio of the Value added (constant 2005 US$) in Agriculture in 1981 to that in 1987?
Your response must be concise. 1.1. What is the ratio of the Value added (constant 2005 US$) in Industry in 1981 to that in 1988?
Make the answer very short. 0.55. What is the ratio of the Value added (constant 2005 US$) in Services in 1981 to that in 1988?
Give a very brief answer. 0.77. What is the ratio of the Value added (constant 2005 US$) of Agriculture in 1981 to that in 1988?
Your response must be concise. 1.07. What is the ratio of the Value added (constant 2005 US$) in Industry in 1981 to that in 1989?
Provide a succinct answer. 0.47. What is the ratio of the Value added (constant 2005 US$) in Services in 1981 to that in 1989?
Make the answer very short. 0.73. What is the ratio of the Value added (constant 2005 US$) in Agriculture in 1981 to that in 1989?
Ensure brevity in your answer.  1.08. What is the ratio of the Value added (constant 2005 US$) in Industry in 1982 to that in 1983?
Give a very brief answer. 1.12. What is the ratio of the Value added (constant 2005 US$) in Services in 1982 to that in 1983?
Provide a succinct answer. 0.95. What is the ratio of the Value added (constant 2005 US$) of Agriculture in 1982 to that in 1983?
Give a very brief answer. 0.98. What is the ratio of the Value added (constant 2005 US$) of Industry in 1982 to that in 1984?
Offer a very short reply. 1.01. What is the ratio of the Value added (constant 2005 US$) in Services in 1982 to that in 1984?
Offer a very short reply. 0.9. What is the ratio of the Value added (constant 2005 US$) of Agriculture in 1982 to that in 1984?
Your answer should be very brief. 0.99. What is the ratio of the Value added (constant 2005 US$) in Industry in 1982 to that in 1985?
Your answer should be very brief. 0.97. What is the ratio of the Value added (constant 2005 US$) of Services in 1982 to that in 1985?
Your response must be concise. 0.89. What is the ratio of the Value added (constant 2005 US$) of Agriculture in 1982 to that in 1985?
Your answer should be compact. 0.9. What is the ratio of the Value added (constant 2005 US$) of Industry in 1982 to that in 1986?
Provide a succinct answer. 0.94. What is the ratio of the Value added (constant 2005 US$) of Services in 1982 to that in 1986?
Your answer should be compact. 0.85. What is the ratio of the Value added (constant 2005 US$) in Agriculture in 1982 to that in 1986?
Offer a very short reply. 0.77. What is the ratio of the Value added (constant 2005 US$) in Industry in 1982 to that in 1987?
Provide a succinct answer. 0.88. What is the ratio of the Value added (constant 2005 US$) in Services in 1982 to that in 1987?
Offer a terse response. 0.82. What is the ratio of the Value added (constant 2005 US$) in Agriculture in 1982 to that in 1987?
Provide a succinct answer. 0.91. What is the ratio of the Value added (constant 2005 US$) in Industry in 1982 to that in 1988?
Ensure brevity in your answer.  0.68. What is the ratio of the Value added (constant 2005 US$) of Services in 1982 to that in 1988?
Keep it short and to the point. 0.78. What is the ratio of the Value added (constant 2005 US$) in Agriculture in 1982 to that in 1988?
Provide a succinct answer. 0.88. What is the ratio of the Value added (constant 2005 US$) in Industry in 1982 to that in 1989?
Ensure brevity in your answer.  0.57. What is the ratio of the Value added (constant 2005 US$) of Services in 1982 to that in 1989?
Your answer should be very brief. 0.74. What is the ratio of the Value added (constant 2005 US$) in Agriculture in 1982 to that in 1989?
Offer a terse response. 0.89. What is the ratio of the Value added (constant 2005 US$) in Industry in 1983 to that in 1984?
Provide a succinct answer. 0.9. What is the ratio of the Value added (constant 2005 US$) in Services in 1983 to that in 1984?
Offer a very short reply. 0.95. What is the ratio of the Value added (constant 2005 US$) of Agriculture in 1983 to that in 1984?
Your response must be concise. 1.01. What is the ratio of the Value added (constant 2005 US$) of Industry in 1983 to that in 1985?
Provide a short and direct response. 0.87. What is the ratio of the Value added (constant 2005 US$) in Services in 1983 to that in 1985?
Your answer should be very brief. 0.93. What is the ratio of the Value added (constant 2005 US$) in Agriculture in 1983 to that in 1985?
Provide a short and direct response. 0.92. What is the ratio of the Value added (constant 2005 US$) of Industry in 1983 to that in 1986?
Give a very brief answer. 0.84. What is the ratio of the Value added (constant 2005 US$) in Services in 1983 to that in 1986?
Offer a terse response. 0.89. What is the ratio of the Value added (constant 2005 US$) of Agriculture in 1983 to that in 1986?
Make the answer very short. 0.79. What is the ratio of the Value added (constant 2005 US$) in Industry in 1983 to that in 1987?
Offer a very short reply. 0.79. What is the ratio of the Value added (constant 2005 US$) in Services in 1983 to that in 1987?
Offer a very short reply. 0.86. What is the ratio of the Value added (constant 2005 US$) in Agriculture in 1983 to that in 1987?
Provide a short and direct response. 0.93. What is the ratio of the Value added (constant 2005 US$) in Industry in 1983 to that in 1988?
Offer a terse response. 0.61. What is the ratio of the Value added (constant 2005 US$) in Services in 1983 to that in 1988?
Provide a short and direct response. 0.82. What is the ratio of the Value added (constant 2005 US$) of Agriculture in 1983 to that in 1988?
Give a very brief answer. 0.9. What is the ratio of the Value added (constant 2005 US$) of Industry in 1983 to that in 1989?
Provide a succinct answer. 0.51. What is the ratio of the Value added (constant 2005 US$) of Services in 1983 to that in 1989?
Provide a short and direct response. 0.77. What is the ratio of the Value added (constant 2005 US$) of Agriculture in 1983 to that in 1989?
Make the answer very short. 0.92. What is the ratio of the Value added (constant 2005 US$) of Industry in 1984 to that in 1985?
Make the answer very short. 0.97. What is the ratio of the Value added (constant 2005 US$) of Agriculture in 1984 to that in 1985?
Keep it short and to the point. 0.91. What is the ratio of the Value added (constant 2005 US$) of Industry in 1984 to that in 1986?
Provide a short and direct response. 0.93. What is the ratio of the Value added (constant 2005 US$) of Services in 1984 to that in 1986?
Make the answer very short. 0.95. What is the ratio of the Value added (constant 2005 US$) in Agriculture in 1984 to that in 1986?
Ensure brevity in your answer.  0.78. What is the ratio of the Value added (constant 2005 US$) in Industry in 1984 to that in 1987?
Your answer should be compact. 0.87. What is the ratio of the Value added (constant 2005 US$) in Services in 1984 to that in 1987?
Your answer should be compact. 0.91. What is the ratio of the Value added (constant 2005 US$) in Agriculture in 1984 to that in 1987?
Your answer should be compact. 0.92. What is the ratio of the Value added (constant 2005 US$) of Industry in 1984 to that in 1988?
Your answer should be very brief. 0.67. What is the ratio of the Value added (constant 2005 US$) of Services in 1984 to that in 1988?
Offer a very short reply. 0.86. What is the ratio of the Value added (constant 2005 US$) in Agriculture in 1984 to that in 1988?
Your answer should be compact. 0.89. What is the ratio of the Value added (constant 2005 US$) of Industry in 1984 to that in 1989?
Your response must be concise. 0.57. What is the ratio of the Value added (constant 2005 US$) of Services in 1984 to that in 1989?
Offer a very short reply. 0.82. What is the ratio of the Value added (constant 2005 US$) in Agriculture in 1984 to that in 1989?
Ensure brevity in your answer.  0.91. What is the ratio of the Value added (constant 2005 US$) of Industry in 1985 to that in 1986?
Make the answer very short. 0.96. What is the ratio of the Value added (constant 2005 US$) in Services in 1985 to that in 1986?
Offer a very short reply. 0.96. What is the ratio of the Value added (constant 2005 US$) of Agriculture in 1985 to that in 1986?
Provide a succinct answer. 0.86. What is the ratio of the Value added (constant 2005 US$) in Industry in 1985 to that in 1987?
Your answer should be very brief. 0.9. What is the ratio of the Value added (constant 2005 US$) in Services in 1985 to that in 1987?
Provide a short and direct response. 0.92. What is the ratio of the Value added (constant 2005 US$) in Agriculture in 1985 to that in 1987?
Ensure brevity in your answer.  1.01. What is the ratio of the Value added (constant 2005 US$) in Industry in 1985 to that in 1988?
Give a very brief answer. 0.69. What is the ratio of the Value added (constant 2005 US$) in Services in 1985 to that in 1988?
Your answer should be very brief. 0.87. What is the ratio of the Value added (constant 2005 US$) of Agriculture in 1985 to that in 1988?
Provide a succinct answer. 0.98. What is the ratio of the Value added (constant 2005 US$) in Industry in 1985 to that in 1989?
Provide a succinct answer. 0.58. What is the ratio of the Value added (constant 2005 US$) of Services in 1985 to that in 1989?
Provide a succinct answer. 0.83. What is the ratio of the Value added (constant 2005 US$) of Agriculture in 1985 to that in 1989?
Offer a very short reply. 0.99. What is the ratio of the Value added (constant 2005 US$) in Industry in 1986 to that in 1987?
Make the answer very short. 0.94. What is the ratio of the Value added (constant 2005 US$) of Services in 1986 to that in 1987?
Provide a short and direct response. 0.96. What is the ratio of the Value added (constant 2005 US$) in Agriculture in 1986 to that in 1987?
Keep it short and to the point. 1.18. What is the ratio of the Value added (constant 2005 US$) of Industry in 1986 to that in 1988?
Ensure brevity in your answer.  0.72. What is the ratio of the Value added (constant 2005 US$) of Agriculture in 1986 to that in 1988?
Offer a very short reply. 1.14. What is the ratio of the Value added (constant 2005 US$) of Industry in 1986 to that in 1989?
Offer a very short reply. 0.61. What is the ratio of the Value added (constant 2005 US$) in Services in 1986 to that in 1989?
Your answer should be very brief. 0.86. What is the ratio of the Value added (constant 2005 US$) of Agriculture in 1986 to that in 1989?
Offer a terse response. 1.16. What is the ratio of the Value added (constant 2005 US$) of Industry in 1987 to that in 1988?
Your answer should be very brief. 0.77. What is the ratio of the Value added (constant 2005 US$) of Services in 1987 to that in 1988?
Keep it short and to the point. 0.95. What is the ratio of the Value added (constant 2005 US$) of Industry in 1987 to that in 1989?
Your answer should be compact. 0.65. What is the ratio of the Value added (constant 2005 US$) in Services in 1987 to that in 1989?
Offer a terse response. 0.9. What is the ratio of the Value added (constant 2005 US$) in Agriculture in 1987 to that in 1989?
Make the answer very short. 0.98. What is the ratio of the Value added (constant 2005 US$) of Industry in 1988 to that in 1989?
Ensure brevity in your answer.  0.84. What is the ratio of the Value added (constant 2005 US$) in Services in 1988 to that in 1989?
Your answer should be compact. 0.94. What is the ratio of the Value added (constant 2005 US$) of Agriculture in 1988 to that in 1989?
Provide a succinct answer. 1.01. What is the difference between the highest and the second highest Value added (constant 2005 US$) of Industry?
Offer a very short reply. 1.80e+07. What is the difference between the highest and the second highest Value added (constant 2005 US$) of Services?
Provide a short and direct response. 2.43e+07. What is the difference between the highest and the second highest Value added (constant 2005 US$) in Agriculture?
Keep it short and to the point. 9.69e+06. What is the difference between the highest and the lowest Value added (constant 2005 US$) of Industry?
Make the answer very short. 6.13e+07. What is the difference between the highest and the lowest Value added (constant 2005 US$) of Services?
Offer a very short reply. 1.18e+08. What is the difference between the highest and the lowest Value added (constant 2005 US$) of Agriculture?
Give a very brief answer. 3.29e+07. 